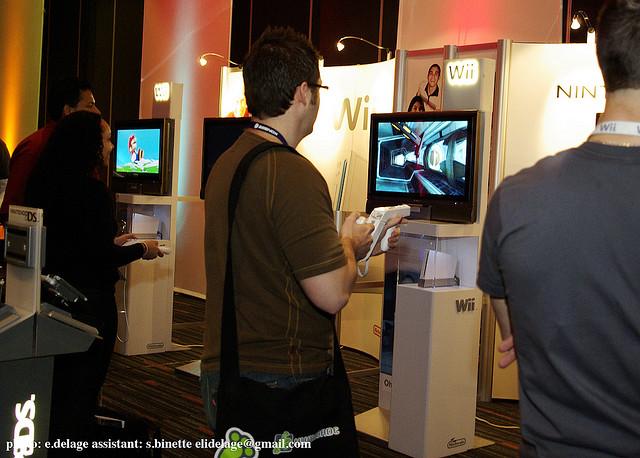How many screens?
Write a very short answer. 2. Is this indoors or outside?
Answer briefly. Indoors. What company is this a booth for?
Quick response, please. Nintendo. What happened for all this to be in the same room?
Quick response, please. Trade show. 